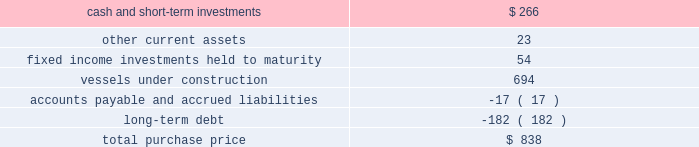Part ii , item 8 fourth quarter of 2007 : 0160 schlumberger sold certain workover rigs for $ 32 million , resulting in a pretax gain of $ 24 million ( $ 17 million after-tax ) which is classified in interest and other income , net in the consolidated statement of income .
Acquisitions acquisition of eastern echo holding plc on december 10 , 2007 , schlumberger completed the acquisition of eastern echo holding plc ( 201ceastern echo 201d ) for $ 838 million in cash .
Eastern echo was a dubai-based marine seismic company that did not have any operations at the time of acquisition , but had signed contracts for the construction of six seismic vessels .
The purchase price has been allocated to the net assets acquired based upon their estimated fair values as follows : ( stated in millions ) .
Other acquisitions schlumberger has made other acquisitions and minority interest investments , none of which were significant on an individual basis , for cash payments , net of cash acquired , of $ 514 million during 2009 , $ 345 million during 2008 , and $ 281 million during 2007 .
Pro forma results pertaining to the above acquisitions are not presented as the impact was not significant .
Drilling fluids joint venture the mi-swaco drilling fluids joint venture is owned 40% ( 40 % ) by schlumberger and 60% ( 60 % ) by smith international , inc .
Schlumberger records income relating to this venture using the equity method of accounting .
The carrying value of schlumberger 2019s investment in the joint venture on december 31 , 2009 and 2008 was $ 1.4 billion and $ 1.3 billion , respectively , and is included within investments in affiliated companies on the consolidated balance sheet .
Schlumberger 2019s equity income from this joint venture was $ 131 million in 2009 , $ 210 million in 2008 and $ 178 million in 2007 .
Schlumberger received cash distributions from the joint venture of $ 106 million in 2009 , $ 57 million in 2008 and $ 46 million in 2007 .
The joint venture agreement contains a provision under which either party to the joint venture may offer to sell its entire interest in the venture to the other party at a cash purchase price per percentage interest specified in an offer notice .
If the offer to sell is not accepted , the offering party will be obligated to purchase the entire interest of the other party at the same price per percentage interest as the prices specified in the offer notice. .
What was cash and short-term investments as a percentage of total purchase price? 
Computations: (266 / 838)
Answer: 0.31742. 